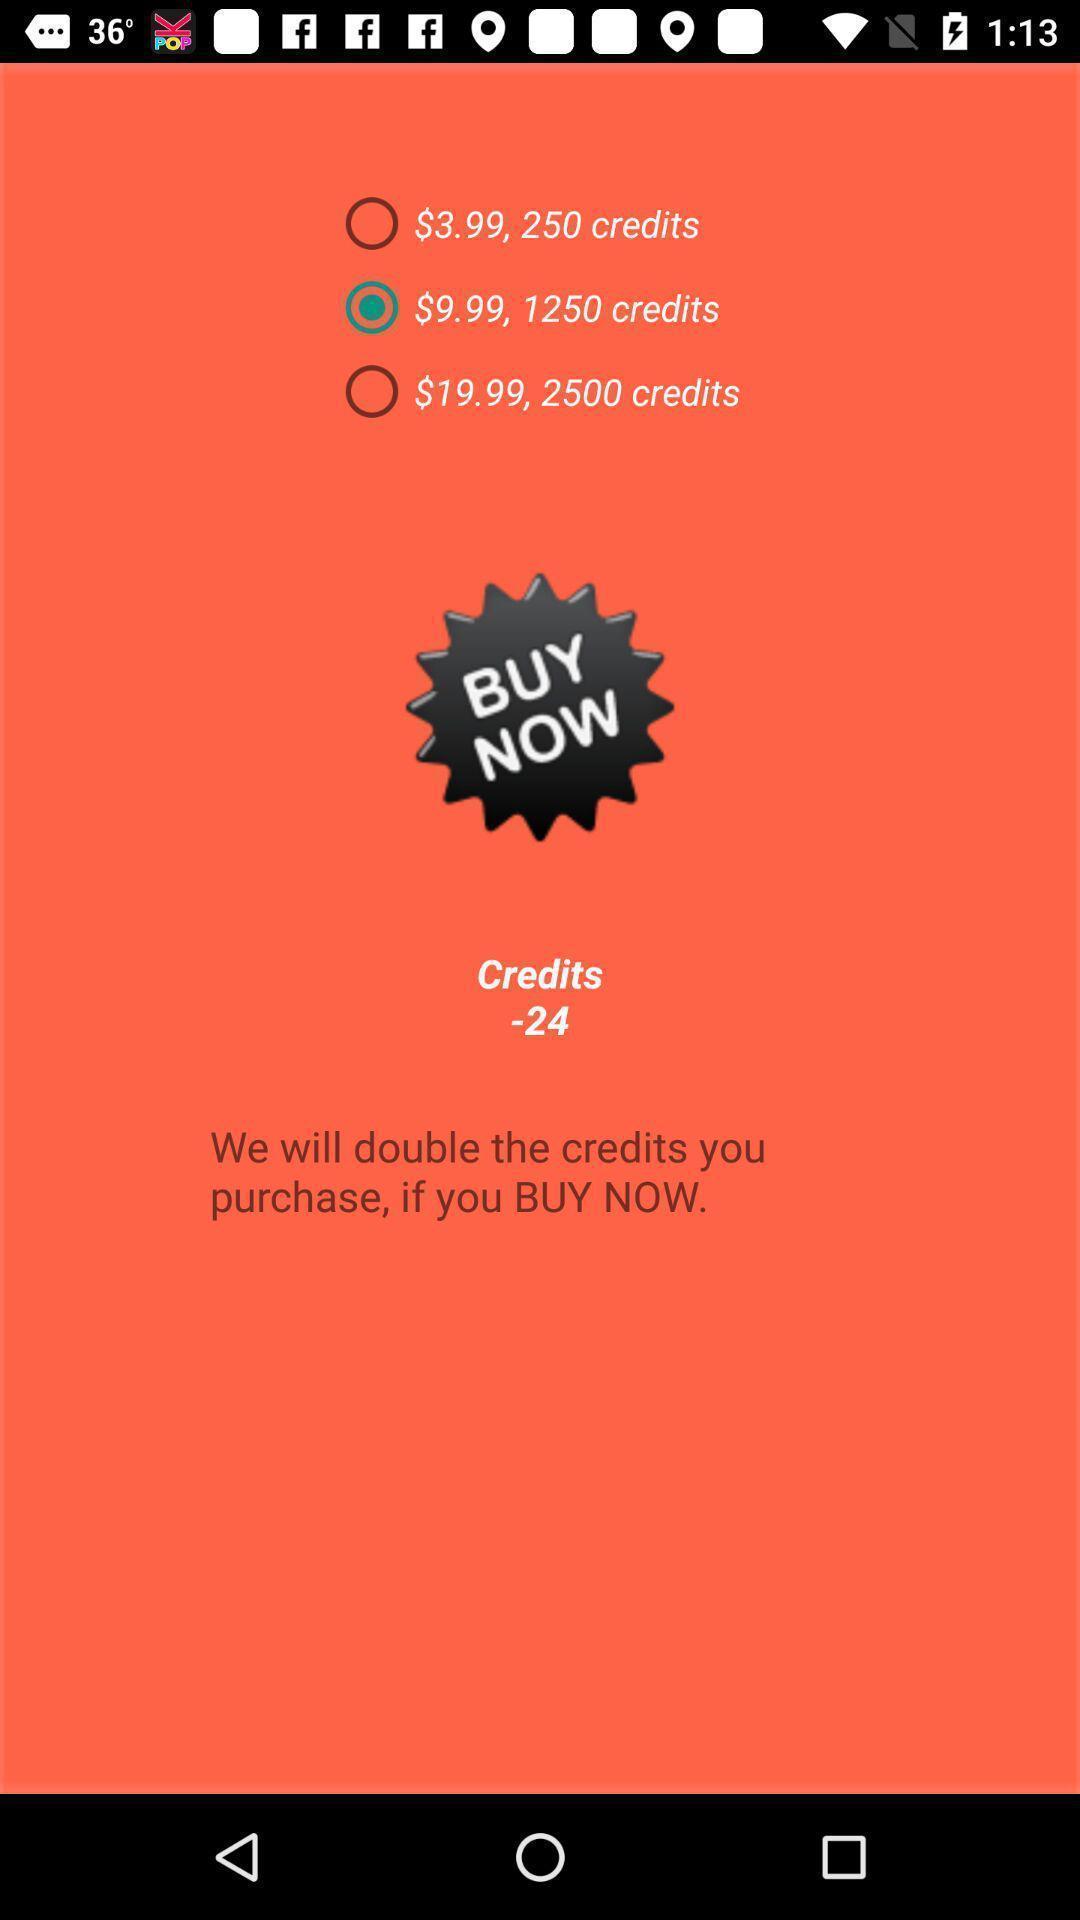Describe the key features of this screenshot. Screen displaying the credits with buy option. 